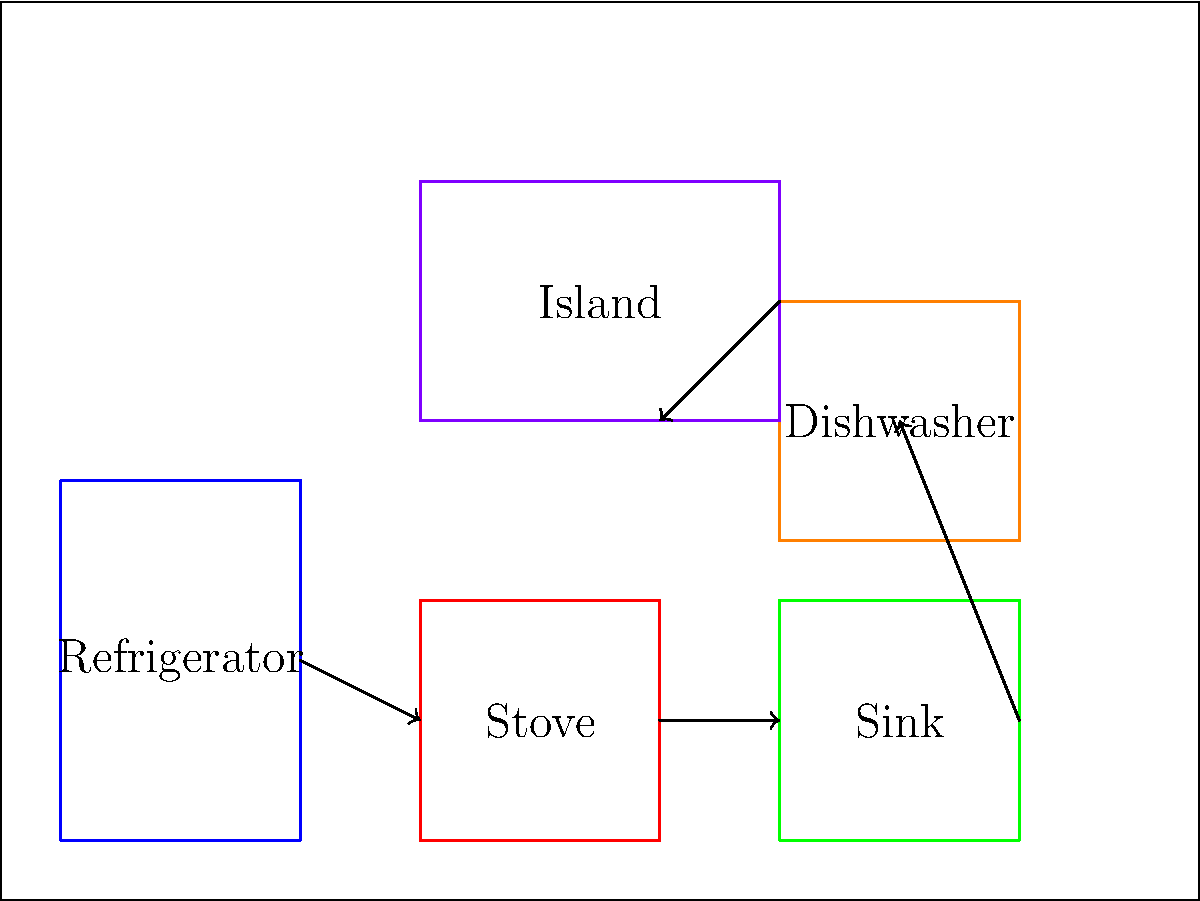As an interior designer working on a kitchen renovation project with your grandparent, you need to optimize the ergonomic layout of the kitchen. Given the appliance dimensions and workflow requirements shown in the diagram, calculate the total distance traveled in the primary workflow path from the refrigerator to the island. Assume that movement between appliances follows straight lines connecting their centers, and movement to the island is to its center. Round your answer to the nearest centimeter, given that 1 unit in the diagram represents 5 cm in the actual kitchen. To solve this problem, we need to follow these steps:

1. Identify the centers of each appliance and the island:
   - Refrigerator: (30, 40)
   - Stove: (90, 30)
   - Sink: (150, 30)
   - Island: (100, 100)

2. Calculate the distances between each point in the workflow:
   a. Refrigerator to Stove:
      $$d_1 = \sqrt{(90-30)^2 + (30-40)^2} = \sqrt{3600 + 100} = \sqrt{3700} \approx 60.83$$

   b. Stove to Sink:
      $$d_2 = \sqrt{(150-90)^2 + (30-30)^2} = \sqrt{3600 + 0} = 60$$

   c. Sink to Island:
      $$d_3 = \sqrt{(100-150)^2 + (100-30)^2} = \sqrt{2500 + 4900} = \sqrt{7400} \approx 86.02$$

3. Sum up the total distance:
   $$d_{total} = d_1 + d_2 + d_3 = 60.83 + 60 + 86.02 = 206.85$$

4. Convert the units:
   Since 1 unit in the diagram represents 5 cm in the actual kitchen, we multiply our result by 5:
   $$d_{actual} = 206.85 * 5 = 1034.25 \text{ cm}$$

5. Round to the nearest centimeter:
   $$d_{final} = 1034 \text{ cm}$$

Therefore, the total distance traveled in the primary workflow path is approximately 1034 cm.
Answer: 1034 cm 